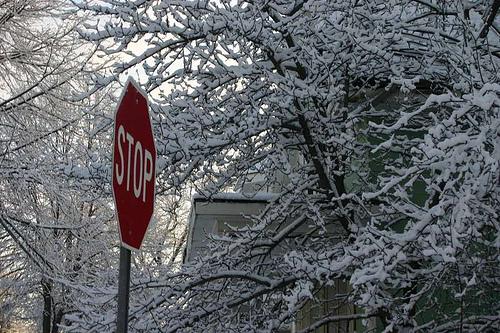Is it cold here?
Answer briefly. Yes. Has it snowed recently?
Concise answer only. Yes. What is the traffic sign?
Answer briefly. Stop. 